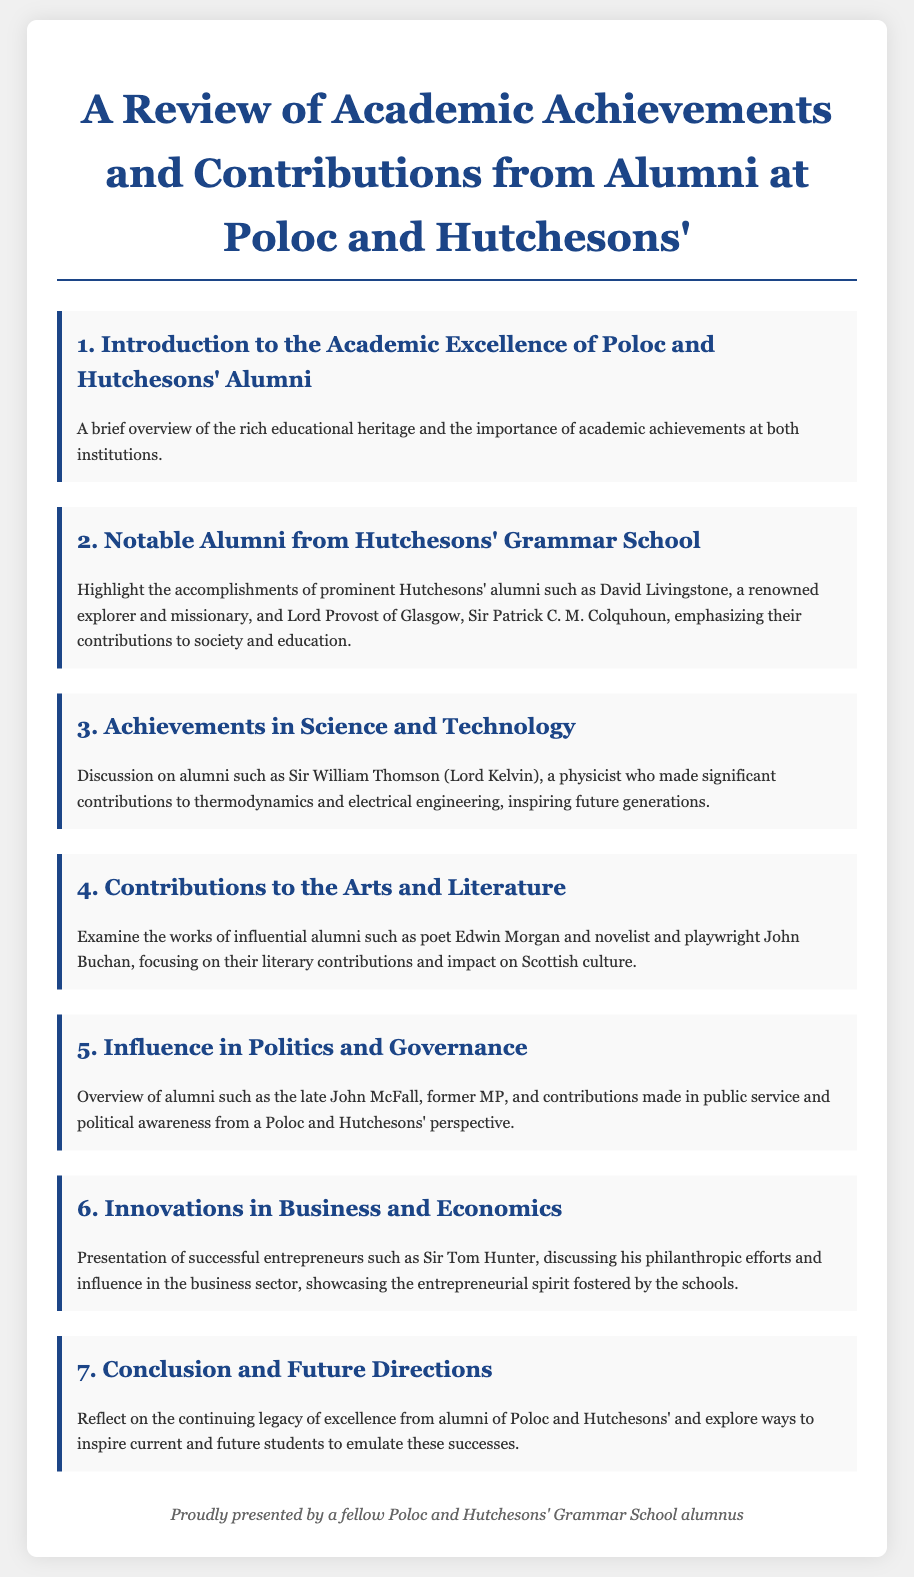What is the title of the document? The title of the document is specified in the header section.
Answer: A Review of Academic Achievements and Contributions from Alumni at Poloc and Hutchesons' Who is mentioned as a notable alumni explorer and missionary? The document highlights notable alumni, specifically naming one in particular in the second agenda item.
Answer: David Livingstone Which physicist known for thermodynamics is recognized in the document? This is found in the third agenda item, which discusses contributions to science and technology.
Answer: Sir William Thomson (Lord Kelvin) What literary contributions are highlighted from the alumni? The fourth agenda item discusses influential alumni and their impact on Scottish culture specifically in literature.
Answer: Edwin Morgan and John Buchan Who is acknowledged for his contributions in politics and governance? The fifth agenda item identifies a specific former MP recognized for public service.
Answer: John McFall What philanthropic effort is associated with Sir Tom Hunter? The sixth agenda item describes successful entrepreneurs and specifically mentions their philanthropic efforts.
Answer: Philanthropic efforts What is the concluding focus of the document? The seventh agenda item reflects on the continuing legacy and aims to inspire current and future students.
Answer: Legacy of excellence 